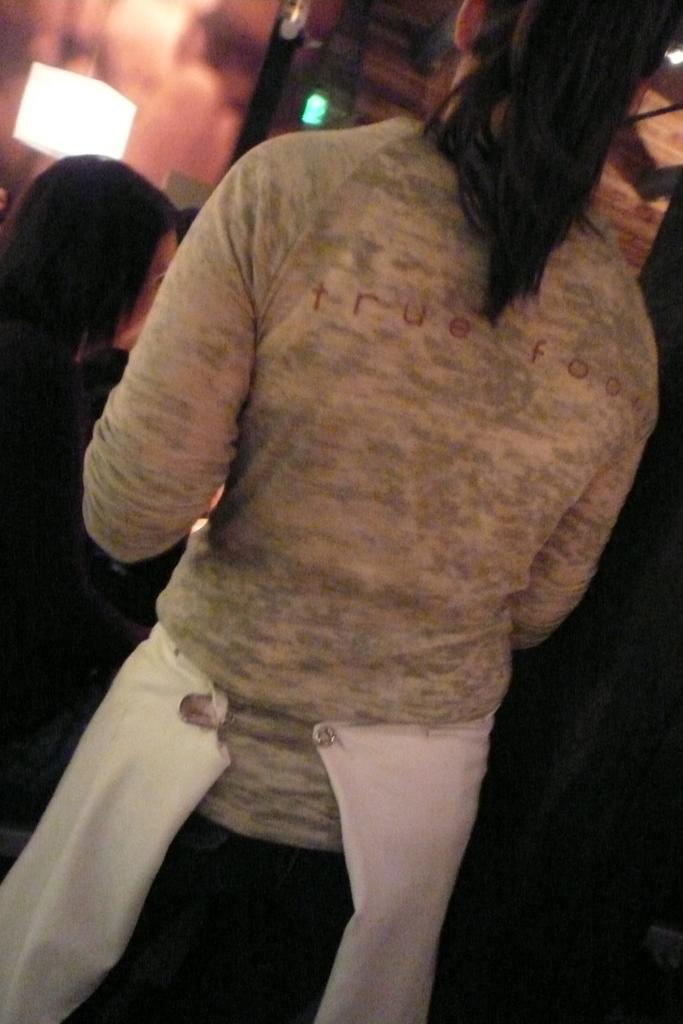Who is present in the image? There is a woman in the image. What is the woman wearing? The woman is wearing a grey T-shirt. Can you describe the positioning of the women in the image? There is another woman in front of the first woman. What can be seen in the background of the image? There is a lamp and a wall in the background of the image. What type of music is the band playing in the image? There is no band present in the image, so it is not possible to determine what type of music they might be playing. 